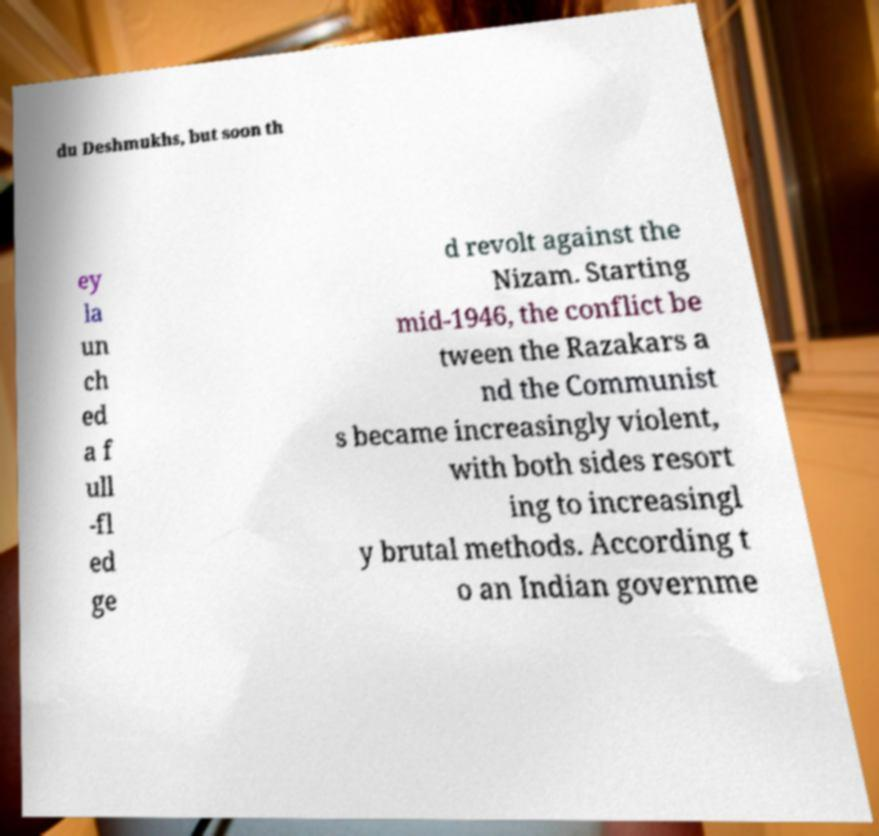Could you assist in decoding the text presented in this image and type it out clearly? du Deshmukhs, but soon th ey la un ch ed a f ull -fl ed ge d revolt against the Nizam. Starting mid-1946, the conflict be tween the Razakars a nd the Communist s became increasingly violent, with both sides resort ing to increasingl y brutal methods. According t o an Indian governme 